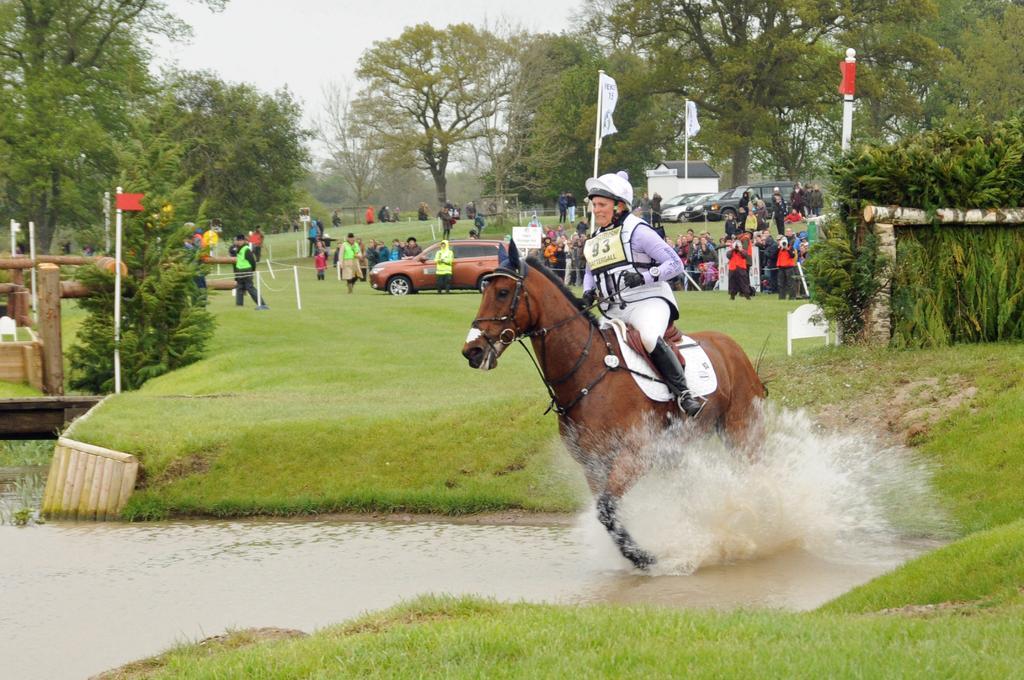How would you summarize this image in a sentence or two? In this image in front there is a person riding a horse in the water. At the bottom of the image there is grass on the surface. There are plants. There are cars. There are people standing in front of the metal fence. There are flags. There are boards. In the background of the image there are trees. There is a building and sky. 